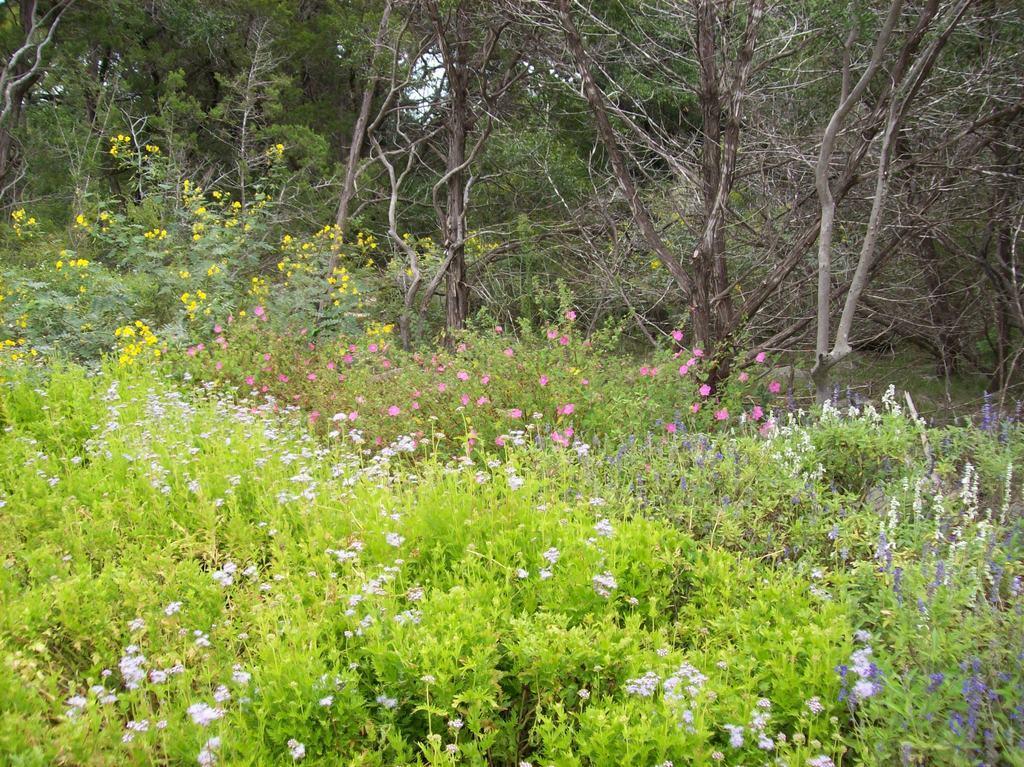Describe this image in one or two sentences. In the image there are flower plants in the foreground and behind the plants there are trees. 